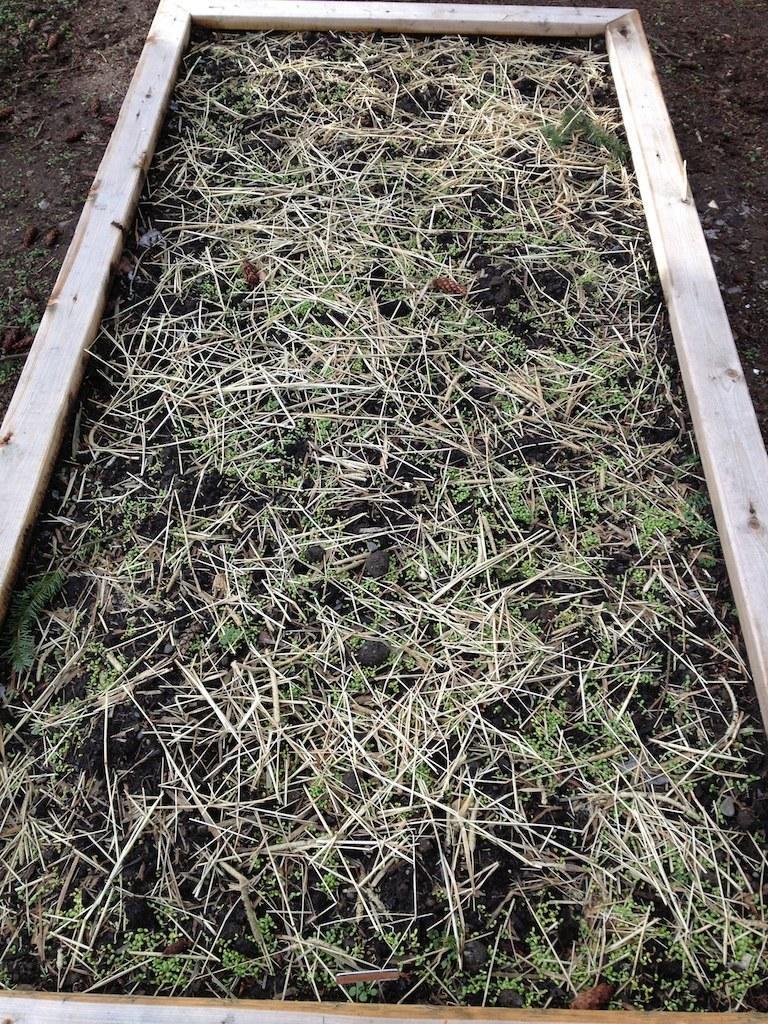Please provide a concise description of this image. In this image there is a wooden tray in which there is grass and soil. 